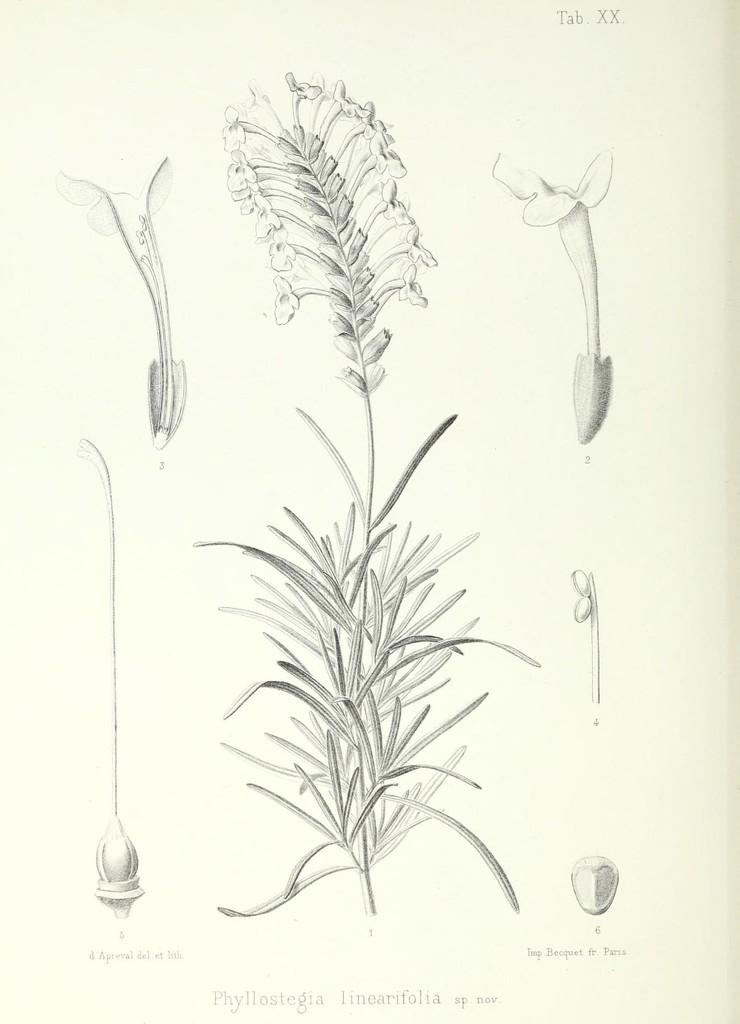What is the main subject of the drawing in the image? The main subject of the drawing is a plant with flowers. Can you identify any specific parts of a flower in the drawing? Yes, parts of a flower are visible in the drawing. Is there any text present in the image? Yes, there is text written on the image. What type of meeting is taking place in the image? There is no meeting present in the image; it is a drawing of a plant with flowers. Can you provide a guide to the friends depicted in the image? There are no friends depicted in the image; it is a drawing of a plant with flowers and text. 